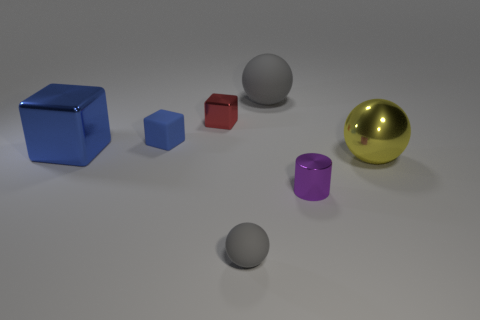Do the object right of the purple shiny thing and the large shiny cube have the same size? Observing the objects to the right of the purple shiny cylinder and the large shiny blue cube, it appears that the red cube is considerably smaller than the blue cube, indicating that they do not have the same size. 